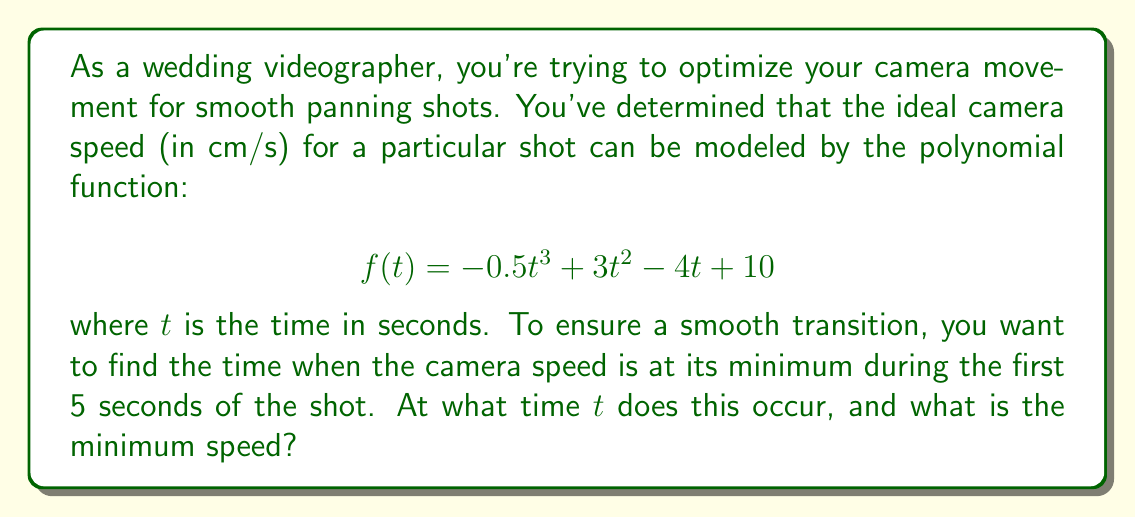Solve this math problem. To solve this problem, we need to follow these steps:

1) First, we need to find the derivative of the function $f(t)$ to determine the rate of change of the camera speed:

   $$f'(t) = -1.5t^2 + 6t - 4$$

2) To find the minimum point, we set the derivative equal to zero and solve for $t$:

   $$-1.5t^2 + 6t - 4 = 0$$

3) This is a quadratic equation. We can solve it using the quadratic formula:

   $$t = \frac{-b \pm \sqrt{b^2 - 4ac}}{2a}$$

   where $a = -1.5$, $b = 6$, and $c = -4$

4) Plugging in these values:

   $$t = \frac{-6 \pm \sqrt{36 - 4(-1.5)(-4)}}{2(-1.5)} = \frac{-6 \pm \sqrt{36 - 24}}{-3} = \frac{-6 \pm \sqrt{12}}{-3}$$

5) Simplifying:

   $$t = \frac{-6 \pm 2\sqrt{3}}{-3} = 2 \mp \frac{2\sqrt{3}}{3}$$

6) This gives us two solutions: $t_1 = 2 + \frac{2\sqrt{3}}{3}$ and $t_2 = 2 - \frac{2\sqrt{3}}{3}$

7) Since we're only interested in the first 5 seconds, and $t_1 > 5$, we focus on $t_2$:

   $$t_2 = 2 - \frac{2\sqrt{3}}{3} \approx 0.845 \text{ seconds}$$

8) To find the minimum speed, we plug this value of $t$ back into our original function:

   $$f(0.845) = -0.5(0.845)^3 + 3(0.845)^2 - 4(0.845) + 10 \approx 8.76 \text{ cm/s}$$

Therefore, the minimum speed occurs at approximately 0.845 seconds and is approximately 8.76 cm/s.
Answer: The minimum camera speed occurs at $t \approx 0.845$ seconds and is approximately 8.76 cm/s. 